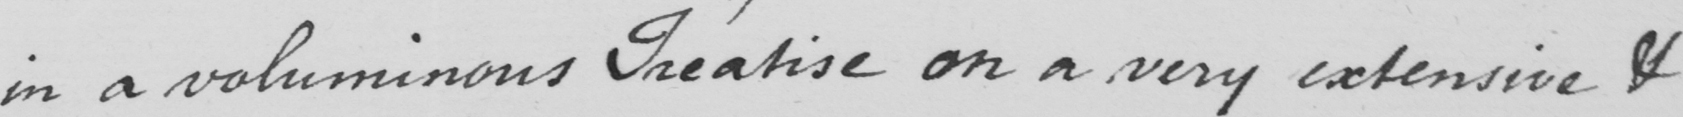What does this handwritten line say? in a voluminous Treatise on a very extensive & 